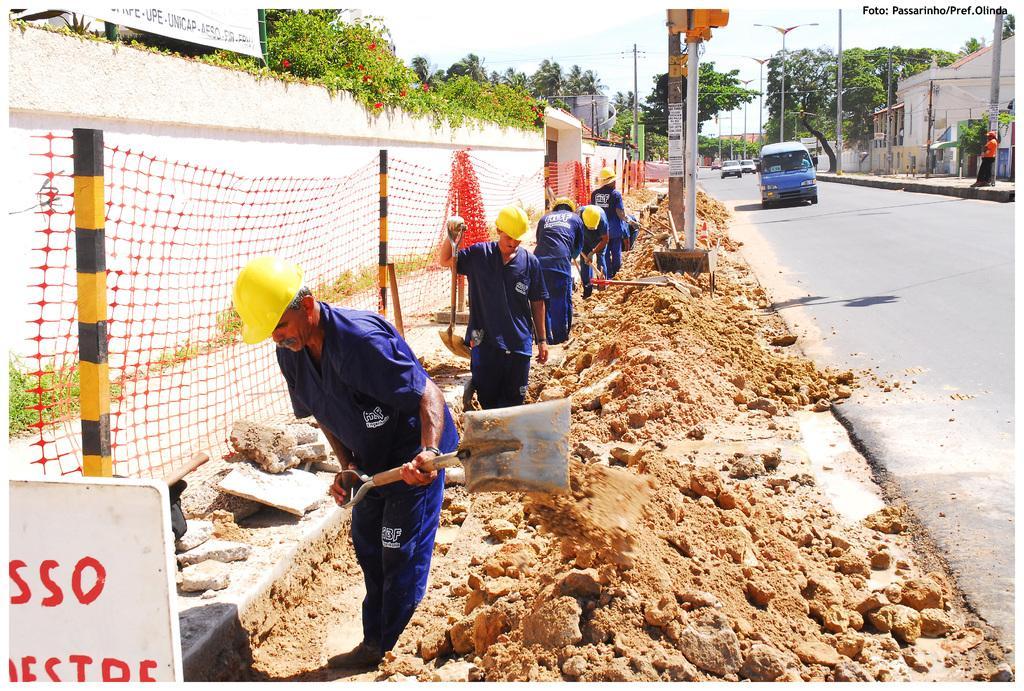Please provide a concise description of this image. In this picture there are people wore helmets and holding tools and we can see stones and board. We can see net, poles and vehicles on the road. On the right side of the image there is a person standing and we can see poles and house. On the left side of the image we can see wall, plants, flowers and board. In the background of the image we can see trees and sky. In the top right side of the image we can see text. 